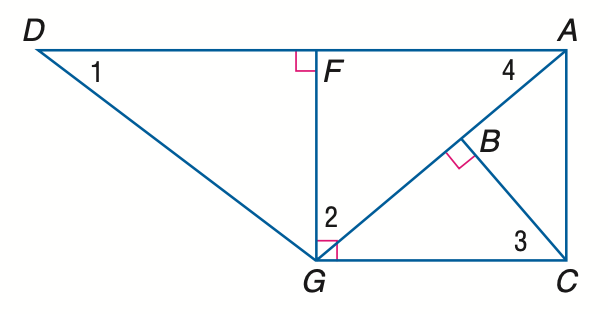Answer the mathemtical geometry problem and directly provide the correct option letter.
Question: Find the measure of \angle 2 if m \angle D G F = 53 and m \angle A G C = 40.
Choices: A: 40 B: 43 C: 50 D: 53 C 